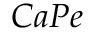<formula> <loc_0><loc_0><loc_500><loc_500>C a P e</formula> 